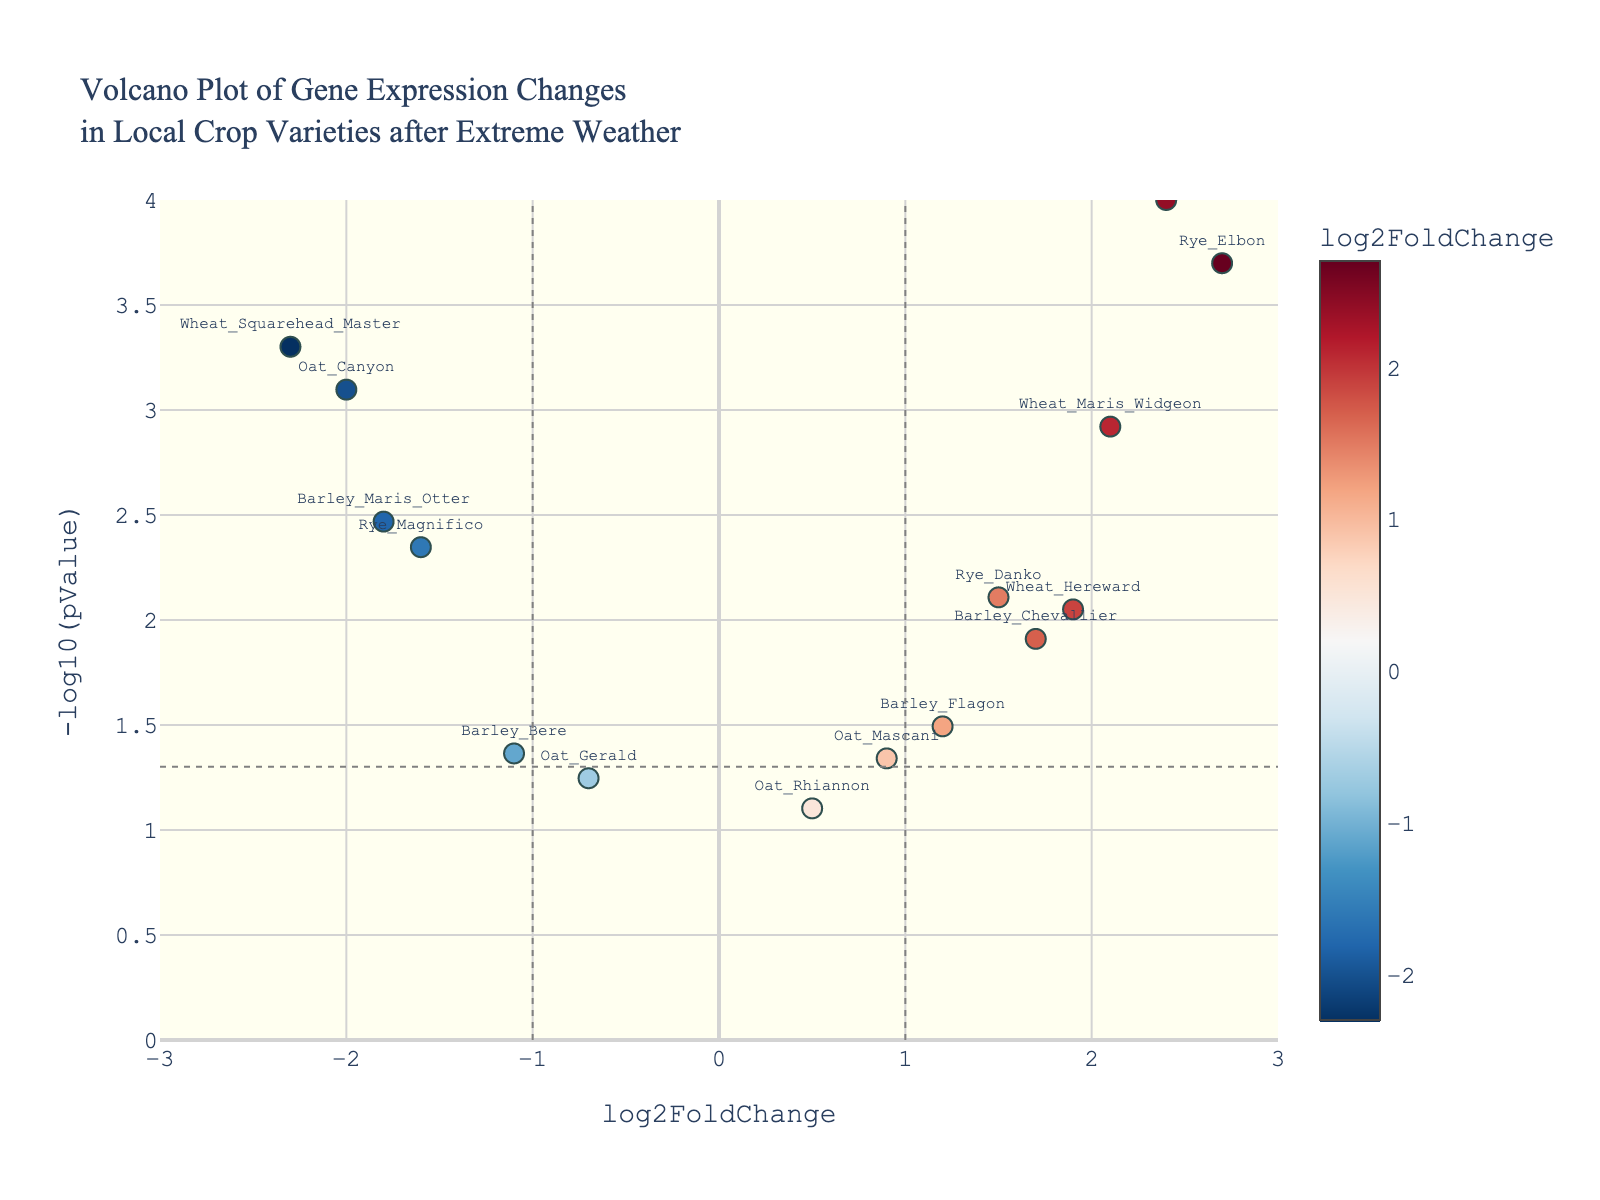What is the title of the figure? The title is usually displayed prominently at the top of the plot. In this case, we look at the top to read the title.
Answer: Volcano Plot of Gene Expression Changes in Local Crop Varieties after Extreme Weather How many genes are labeled in the plot? Each point in the plot typically represents a gene, and each has a label with the gene name. Count the labels on the plot.
Answer: 14 What does a negative log2FoldChange indicate? In a volcano plot, a negative log2FoldChange means that the expression of the gene is downregulated after the extreme weather events.
Answer: Downregulation Which gene has the highest -log10(pValue) and what is its log2FoldChange? To find this, identify the point that is farthest above the x-axis, then read its label and log2FoldChange value.
Answer: Rye_Elbon, 2.7 Are there any genes with a pValue greater than 0.05? A horizontal line at y = -log10(0.05) can be used as a threshold, check if any points are below this line.
Answer: Yes, Oat_Gerald and Oat_Rhiannon What does it mean if a gene is located to the far right of the plot? Points on the right side of the plot have positive log2FoldChanges indicating upregulation after extreme weather events.
Answer: Upregulation Which gene has the most extreme downregulation? Extreme downregulation would be indicated by the most negative log2FoldChange value. Find the point farthest to the left on the x-axis.
Answer: Wheat_Squarehead_Master How does the expression change of Oat_Canyon compare to that of Barley_Maris_Otter in terms of log2FoldChange? Compare the log2FoldChange values of Oat_Canyon (-2.0) and Barley_Maris_Otter (-1.8).
Answer: Oat_Canyon has a more negative value How many genes have a log2FoldChange greater than 1? Count all data points to the right of the vertical line at x=1.
Answer: 6 What can be concluded about the gene 'Wheat_Paragon'? Examine both the log2FoldChange and -log10(pValue) for context. Wheat_Paragon has a log2FoldChange of 2.4 and a very high -log10(pValue).
Answer: Strongly upregulated and highly significant 